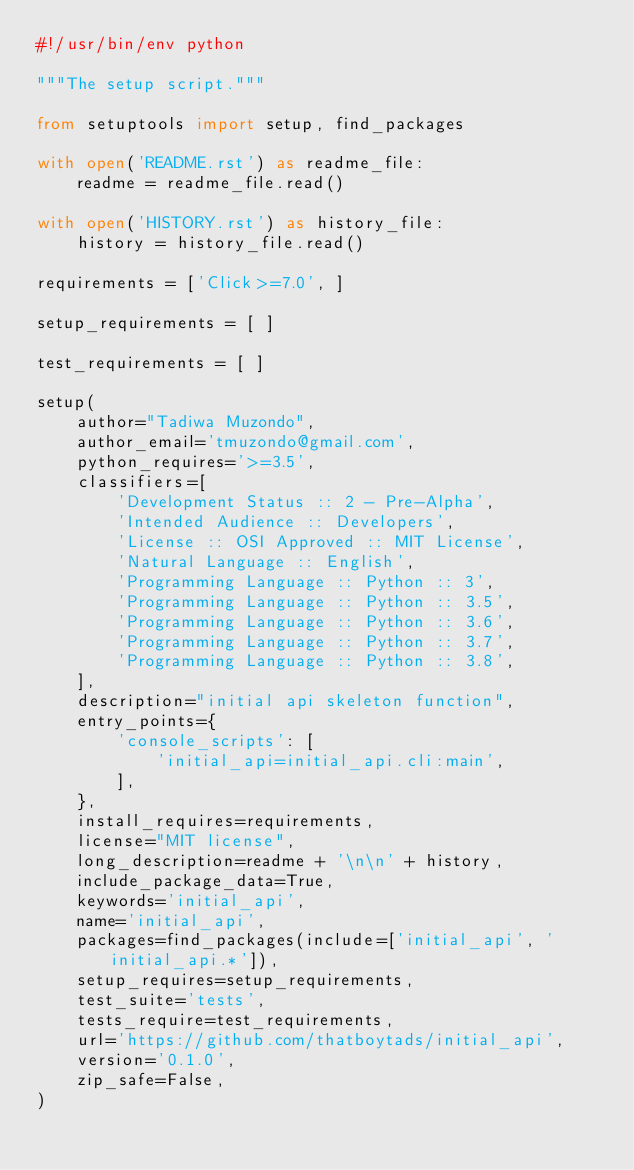<code> <loc_0><loc_0><loc_500><loc_500><_Python_>#!/usr/bin/env python

"""The setup script."""

from setuptools import setup, find_packages

with open('README.rst') as readme_file:
    readme = readme_file.read()

with open('HISTORY.rst') as history_file:
    history = history_file.read()

requirements = ['Click>=7.0', ]

setup_requirements = [ ]

test_requirements = [ ]

setup(
    author="Tadiwa Muzondo",
    author_email='tmuzondo@gmail.com',
    python_requires='>=3.5',
    classifiers=[
        'Development Status :: 2 - Pre-Alpha',
        'Intended Audience :: Developers',
        'License :: OSI Approved :: MIT License',
        'Natural Language :: English',
        'Programming Language :: Python :: 3',
        'Programming Language :: Python :: 3.5',
        'Programming Language :: Python :: 3.6',
        'Programming Language :: Python :: 3.7',
        'Programming Language :: Python :: 3.8',
    ],
    description="initial api skeleton function",
    entry_points={
        'console_scripts': [
            'initial_api=initial_api.cli:main',
        ],
    },
    install_requires=requirements,
    license="MIT license",
    long_description=readme + '\n\n' + history,
    include_package_data=True,
    keywords='initial_api',
    name='initial_api',
    packages=find_packages(include=['initial_api', 'initial_api.*']),
    setup_requires=setup_requirements,
    test_suite='tests',
    tests_require=test_requirements,
    url='https://github.com/thatboytads/initial_api',
    version='0.1.0',
    zip_safe=False,
)
</code> 